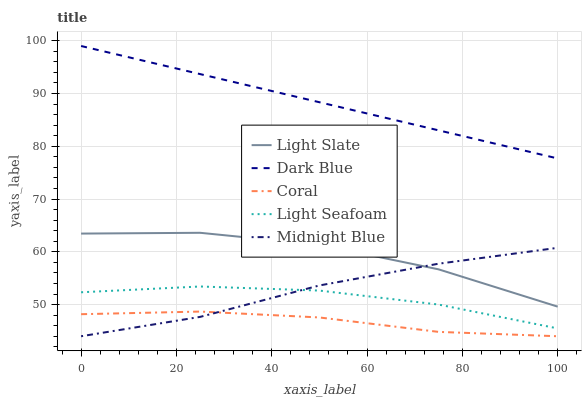Does Coral have the minimum area under the curve?
Answer yes or no. Yes. Does Dark Blue have the maximum area under the curve?
Answer yes or no. Yes. Does Dark Blue have the minimum area under the curve?
Answer yes or no. No. Does Coral have the maximum area under the curve?
Answer yes or no. No. Is Dark Blue the smoothest?
Answer yes or no. Yes. Is Light Slate the roughest?
Answer yes or no. Yes. Is Coral the smoothest?
Answer yes or no. No. Is Coral the roughest?
Answer yes or no. No. Does Dark Blue have the lowest value?
Answer yes or no. No. Does Dark Blue have the highest value?
Answer yes or no. Yes. Does Coral have the highest value?
Answer yes or no. No. Is Coral less than Light Slate?
Answer yes or no. Yes. Is Dark Blue greater than Coral?
Answer yes or no. Yes. Does Midnight Blue intersect Light Seafoam?
Answer yes or no. Yes. Is Midnight Blue less than Light Seafoam?
Answer yes or no. No. Is Midnight Blue greater than Light Seafoam?
Answer yes or no. No. Does Coral intersect Light Slate?
Answer yes or no. No. 